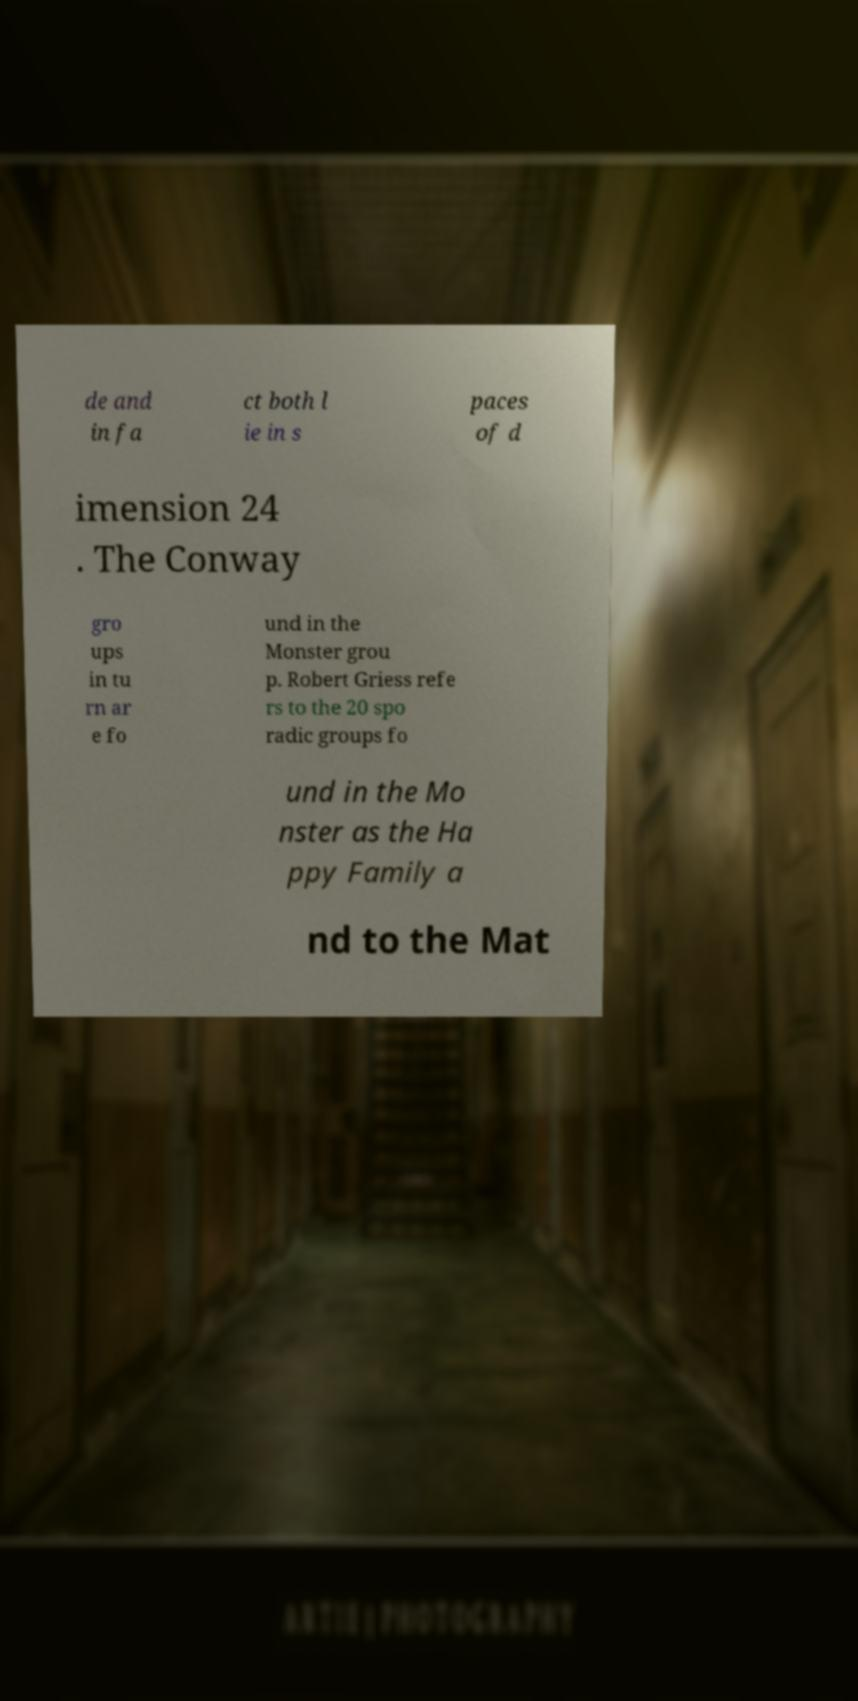There's text embedded in this image that I need extracted. Can you transcribe it verbatim? de and in fa ct both l ie in s paces of d imension 24 . The Conway gro ups in tu rn ar e fo und in the Monster grou p. Robert Griess refe rs to the 20 spo radic groups fo und in the Mo nster as the Ha ppy Family a nd to the Mat 